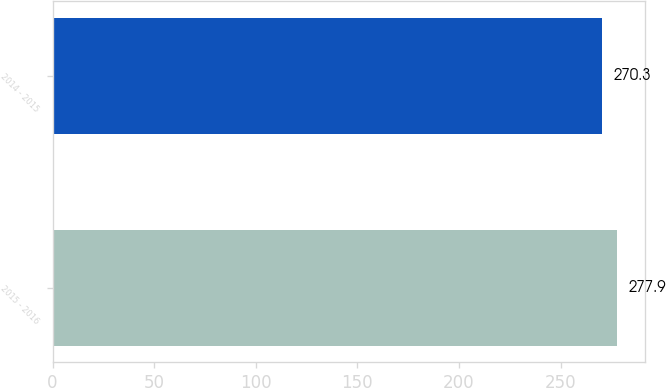Convert chart to OTSL. <chart><loc_0><loc_0><loc_500><loc_500><bar_chart><fcel>2015 - 2016<fcel>2014 - 2015<nl><fcel>277.9<fcel>270.3<nl></chart> 